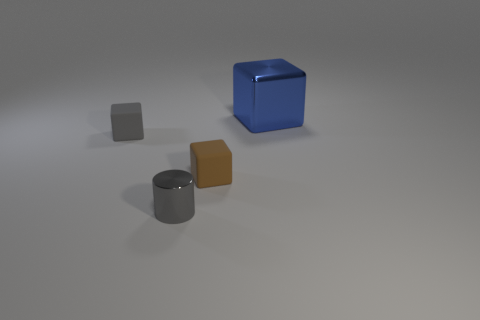There is a small gray object in front of the tiny thing to the left of the small object in front of the brown cube; what is its shape?
Offer a terse response. Cylinder. Are there any gray metal things that have the same size as the shiny cylinder?
Provide a short and direct response. No. The brown rubber cube has what size?
Ensure brevity in your answer.  Small. What number of gray shiny cylinders are the same size as the blue block?
Your answer should be very brief. 0. Are there fewer small cylinders on the right side of the blue shiny block than large metallic cubes behind the small gray cube?
Offer a terse response. Yes. There is a shiny object to the left of the tiny cube right of the metallic object in front of the large blue cube; what is its size?
Offer a terse response. Small. There is a object that is on the left side of the brown matte object and behind the small brown rubber object; what size is it?
Keep it short and to the point. Small. What is the shape of the tiny thing that is left of the metal object in front of the big blue cube?
Provide a short and direct response. Cube. Are there any other things that have the same color as the metallic cylinder?
Provide a succinct answer. Yes. What shape is the metal object that is on the left side of the large blue metallic thing?
Provide a succinct answer. Cylinder. 